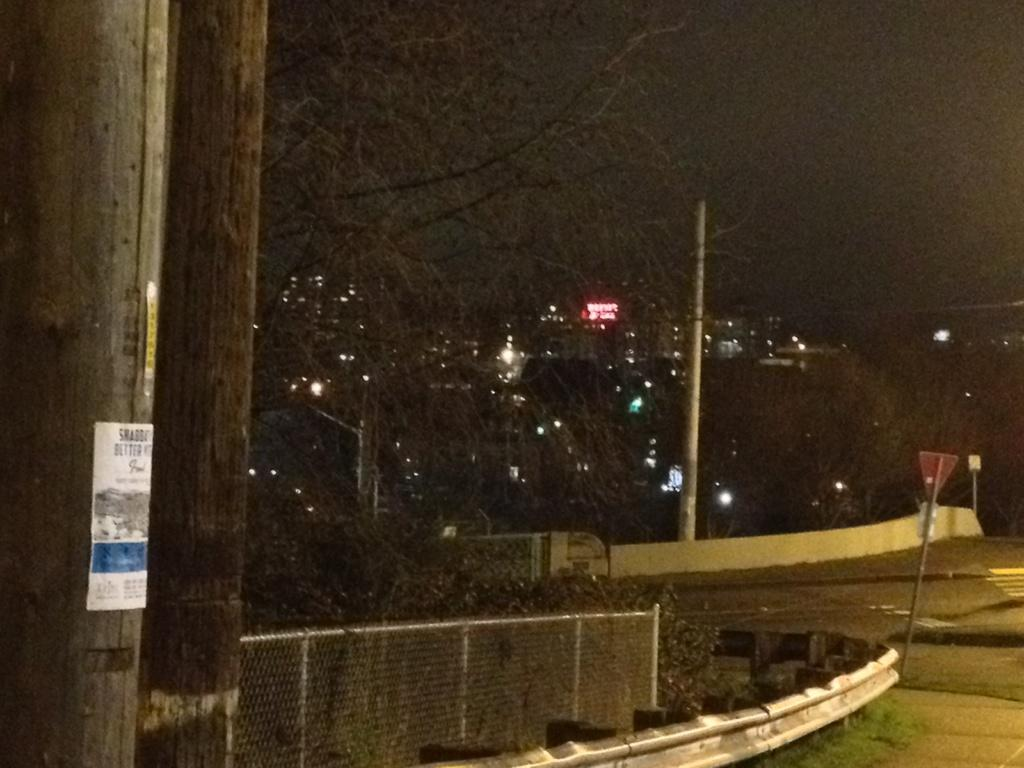What is on the pole in the image? There is a poster on a pole in the image. What type of structure can be seen in the image? There is a fence in the image. What is the main pathway visible in the image? There is a road in the image. What type of signage is present in the image? There are boards in the image. What type of vegetation is present in the image? There are trees in the image. What type of lighting is present in the image? There are lights in the image. What type of electronic signage is present in the image? There is an LED board in the image. What is the color of the sky in the background of the image? The sky in the background of the image is dark. Can you see a feather floating in the air in the image? There is no feather visible in the image. How does the person in the image show respect? There is no person present in the image, so it is not possible to determine how they might show respect. 